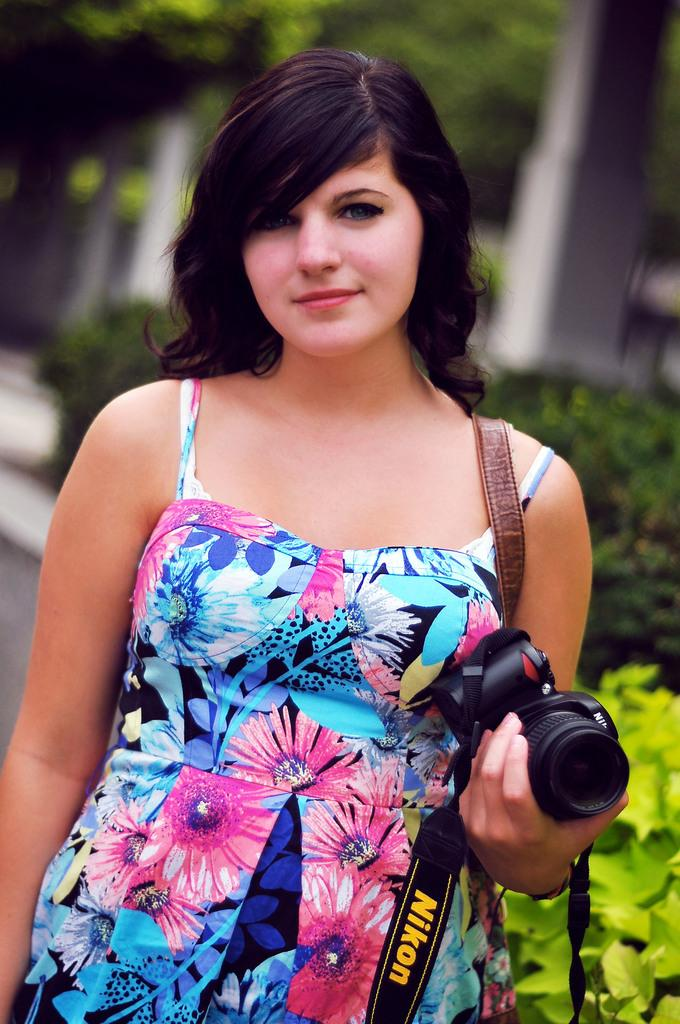Who is present in the image? There is a woman in the image. What is the woman holding in her hand? The woman is holding a camera in her hand. What type of vegetation can be seen in the image? There are plants and trees in the image. What architectural feature is visible in the image? There is a pillar in the image. What type of rhythm can be heard coming from the bucket in the image? There is no bucket present in the image, so it is not possible to determine what rhythm might be heard. 